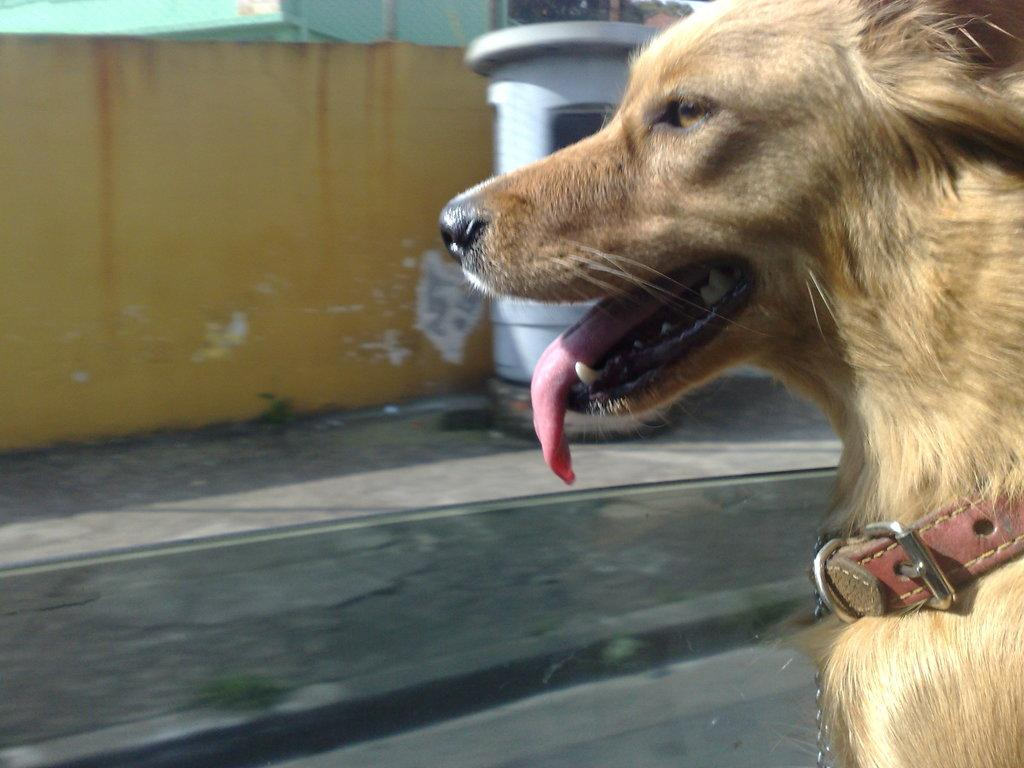What type of animal is in the image? There is a dog in the image. What color is the dog? The dog is brown in color. What can be seen in the background of the image? There is a wall and a building in the background of the image. What colors are the wall and building? The wall is yellow in color, and the building is green in color. What type of error can be seen in the dog's throat in the image? There is no error or throat visible in the image, as it features a dog and background elements. 